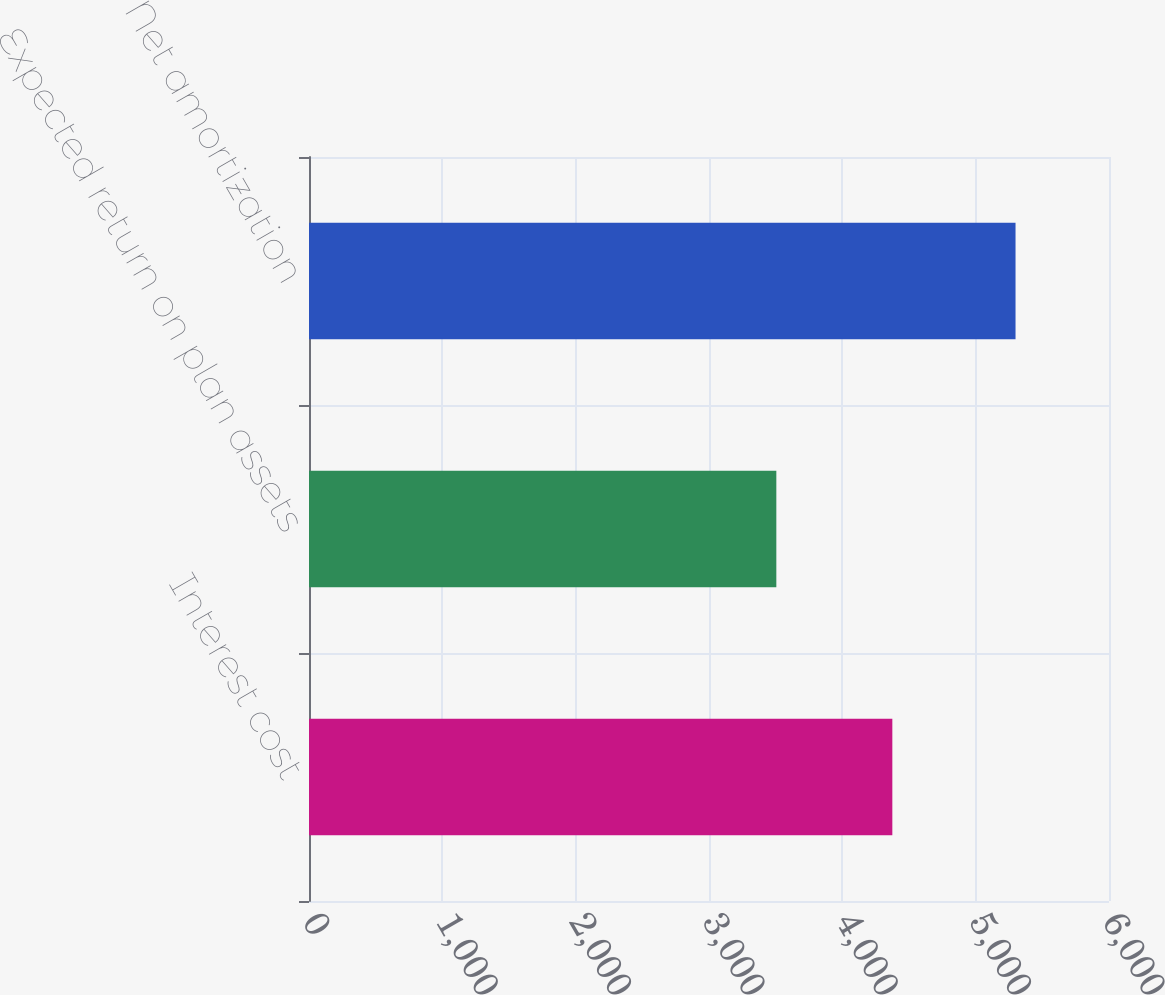<chart> <loc_0><loc_0><loc_500><loc_500><bar_chart><fcel>Interest cost<fcel>Expected return on plan assets<fcel>Net amortization<nl><fcel>4375<fcel>3505<fcel>5299<nl></chart> 